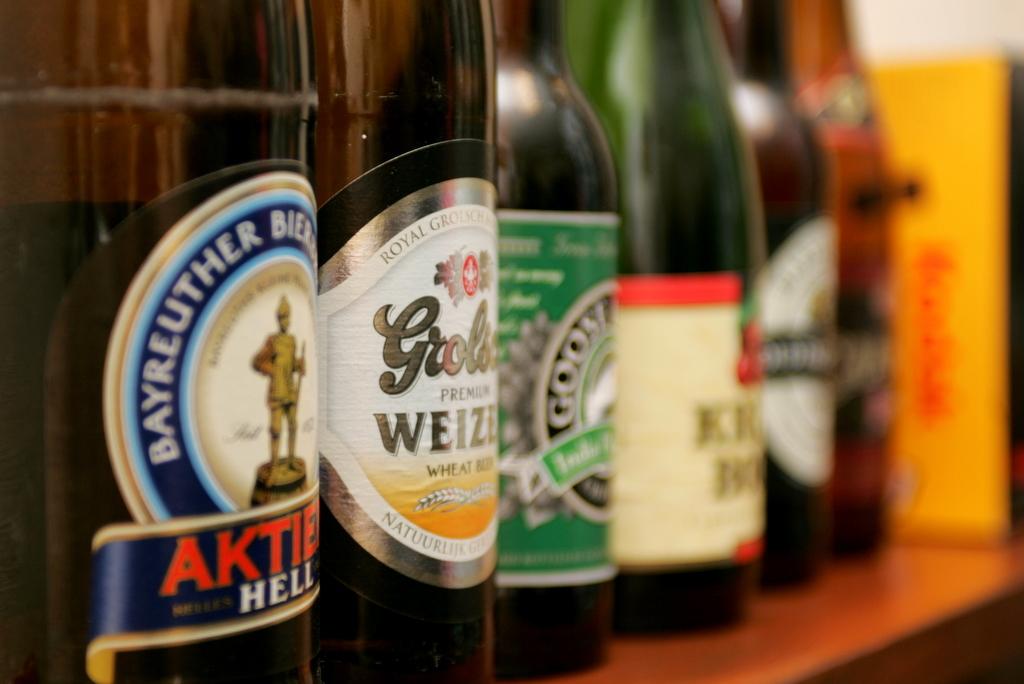What is the first letter of the name of the bottle on the left?
Keep it short and to the point. A. 